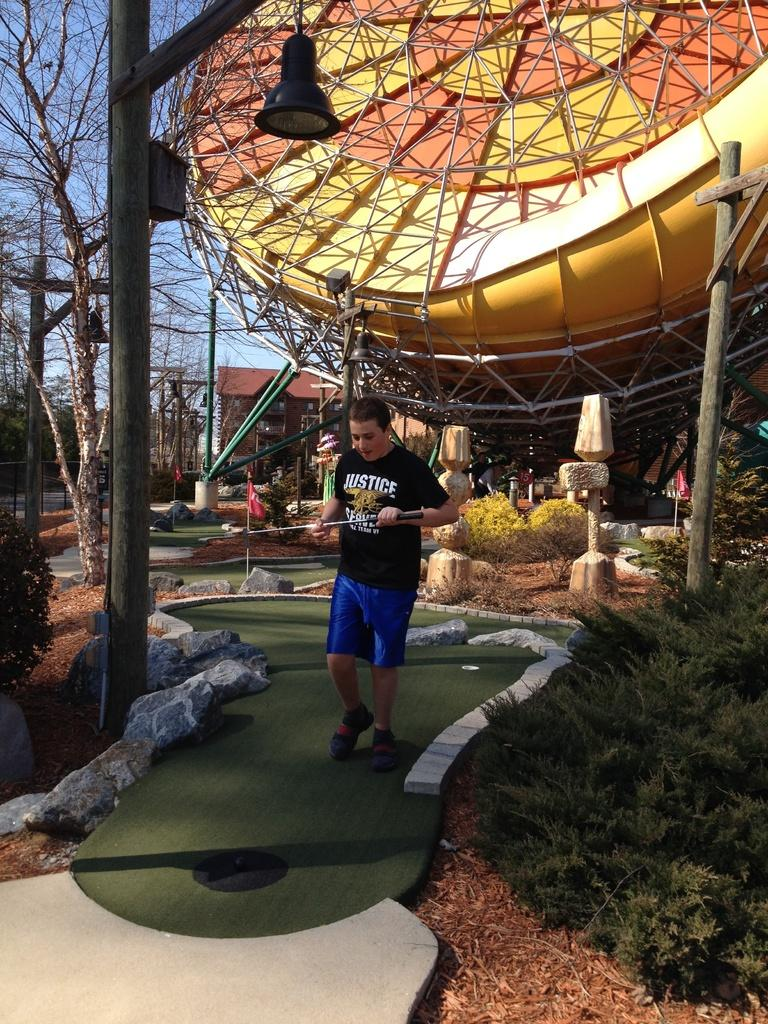What is the person in the image doing? There is a person walking in the image. What is the person carrying while walking? The person is carrying an object. Can you describe any light source in the image? There is a lamp in the image. What type of vegetation can be seen in the image? Plants and trees are visible in the image. What type of paste is being used to fix the box in the image? There is no box or paste present in the image. 